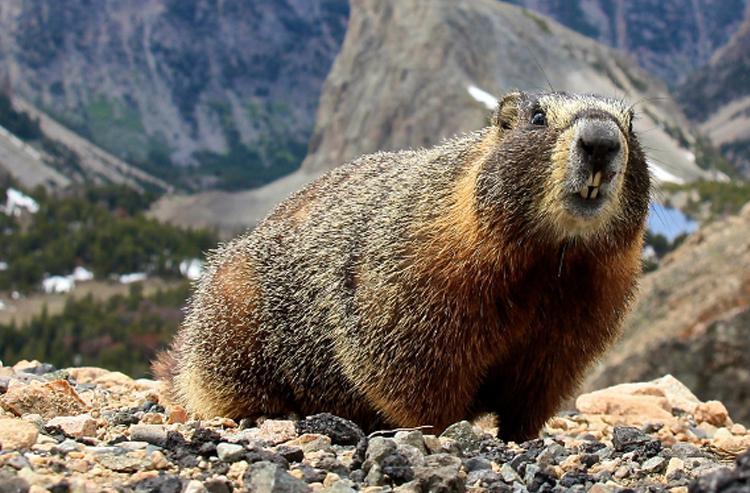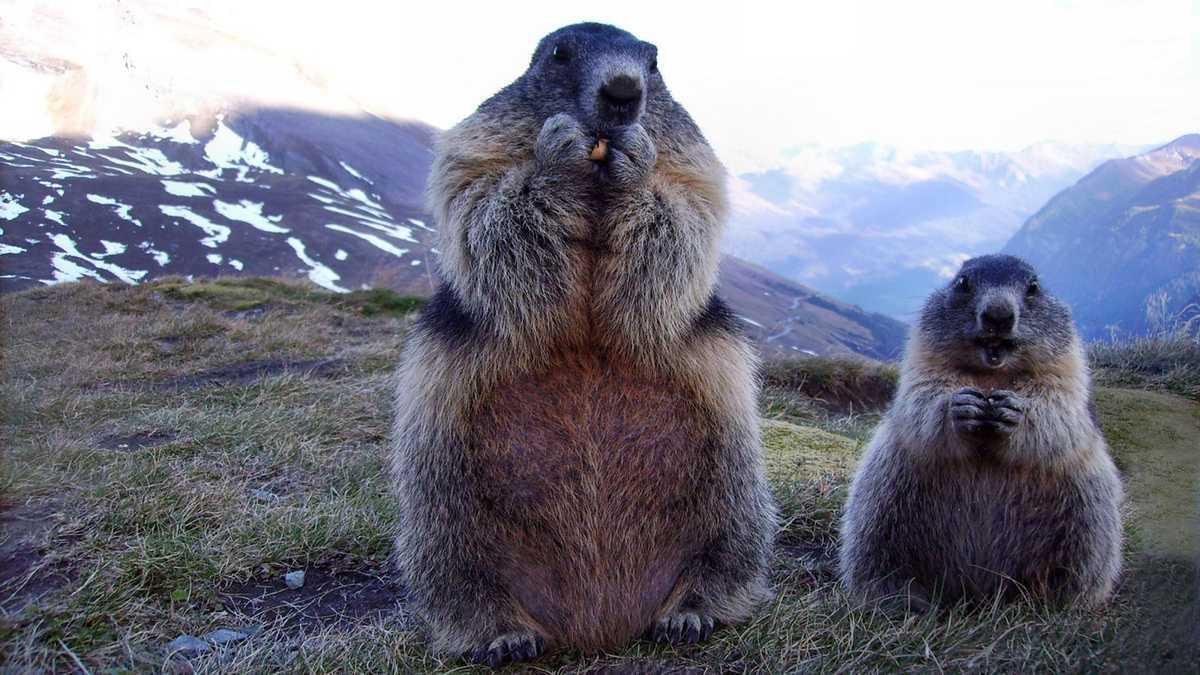The first image is the image on the left, the second image is the image on the right. Given the left and right images, does the statement "Two animals are eating in the image on the right." hold true? Answer yes or no. Yes. The first image is the image on the left, the second image is the image on the right. Analyze the images presented: Is the assertion "Right image shows two upright marmots with hands clasping something." valid? Answer yes or no. Yes. 